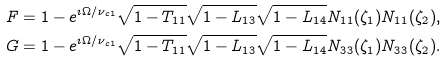<formula> <loc_0><loc_0><loc_500><loc_500>F & = 1 - e ^ { \imath \Omega / \nu _ { c 1 } } \sqrt { 1 - T _ { 1 1 } } \sqrt { 1 - L _ { 1 3 } } \sqrt { 1 - L _ { 1 4 } } N _ { 1 1 } ( \zeta _ { 1 } ) N _ { 1 1 } ( \zeta _ { 2 } ) , \\ G & = 1 - e ^ { \imath \Omega / \nu _ { c 1 } } \sqrt { 1 - T _ { 1 1 } } \sqrt { 1 - L _ { 1 3 } } \sqrt { 1 - L _ { 1 4 } } N _ { 3 3 } ( \zeta _ { 1 } ) N _ { 3 3 } ( \zeta _ { 2 } ) .</formula> 